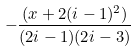<formula> <loc_0><loc_0><loc_500><loc_500>- { \frac { ( x + 2 ( i - 1 ) ^ { 2 } ) } { ( 2 i - 1 ) ( 2 i - 3 ) } }</formula> 